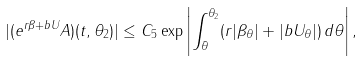<formula> <loc_0><loc_0><loc_500><loc_500>| ( e ^ { r \beta + b U } A ) ( t , \theta _ { 2 } ) | \leq C _ { 5 } \exp \left | \int _ { \bar { \theta } } ^ { \theta _ { 2 } } ( r | \beta _ { \theta } | + | b U _ { \theta } | ) \, d \theta \right | ,</formula> 